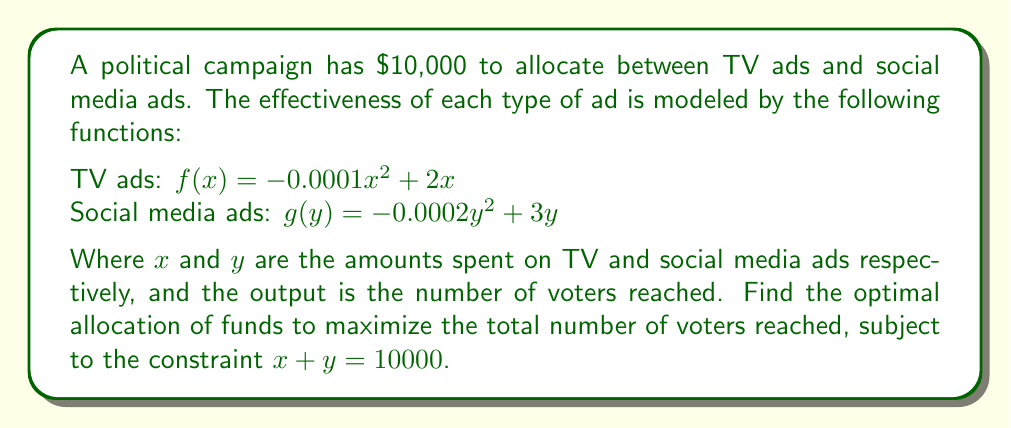What is the answer to this math problem? 1) We want to maximize the total number of voters reached, which is given by:
   $h(x,y) = f(x) + g(y) = (-0.0001x^2 + 2x) + (-0.0002y^2 + 3y)$

2) We have the constraint $x + y = 10000$. We can express $y$ in terms of $x$:
   $y = 10000 - x$

3) Substituting this into our function:
   $h(x) = (-0.0001x^2 + 2x) + (-0.0002(10000-x)^2 + 3(10000-x))$

4) Expanding:
   $h(x) = -0.0001x^2 + 2x - 0.0002(100000000 - 20000x + x^2) + 30000 - 3x$
   $h(x) = -0.0001x^2 + 2x - 20000 + 4x - 0.0002x^2 + 30000 - 3x$
   $h(x) = -0.0003x^2 + 3x + 10000$

5) To find the maximum, we differentiate and set to zero:
   $h'(x) = -0.0006x + 3 = 0$
   $-0.0006x = -3$
   $x = 5000$

6) The second derivative $h''(x) = -0.0006$ is negative, confirming this is a maximum.

7) Since $x = 5000$, $y = 10000 - 5000 = 5000$

8) Therefore, the optimal allocation is $5000 to TV ads and $5000 to social media ads.
Answer: $5000 for TV ads, $5000 for social media ads 